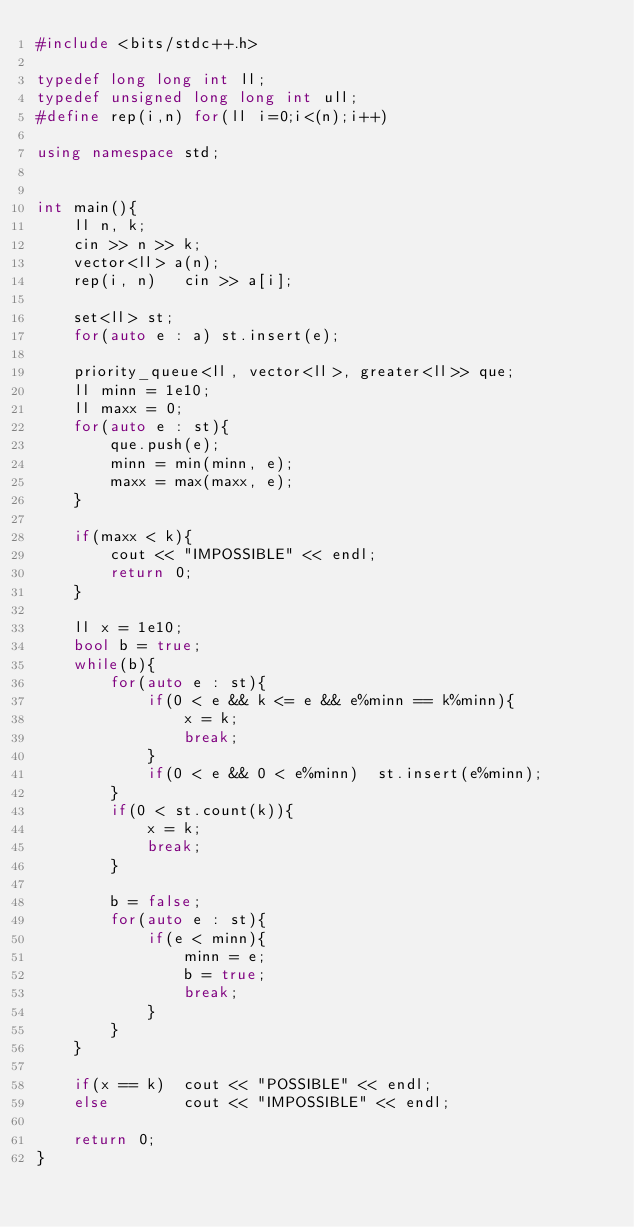<code> <loc_0><loc_0><loc_500><loc_500><_C++_>#include <bits/stdc++.h>
 
typedef long long int ll;
typedef unsigned long long int ull;
#define rep(i,n) for(ll i=0;i<(n);i++)
 
using namespace std;


int main(){
    ll n, k;
    cin >> n >> k;
    vector<ll> a(n);
    rep(i, n)   cin >> a[i];

    set<ll> st;
    for(auto e : a) st.insert(e);

    priority_queue<ll, vector<ll>, greater<ll>> que;
    ll minn = 1e10;
    ll maxx = 0;
    for(auto e : st){
        que.push(e);
        minn = min(minn, e);
        maxx = max(maxx, e);
    }

    if(maxx < k){
        cout << "IMPOSSIBLE" << endl;
        return 0;
    }

    ll x = 1e10;
    bool b = true;
    while(b){
        for(auto e : st){
            if(0 < e && k <= e && e%minn == k%minn){
                x = k;
                break;
            }
            if(0 < e && 0 < e%minn)  st.insert(e%minn);
        }
        if(0 < st.count(k)){
            x = k;
            break;
        }

        b = false;
        for(auto e : st){
            if(e < minn){
                minn = e;
                b = true;
                break;
            }
        }
    }

    if(x == k)  cout << "POSSIBLE" << endl;
    else        cout << "IMPOSSIBLE" << endl;

    return 0;
}
</code> 